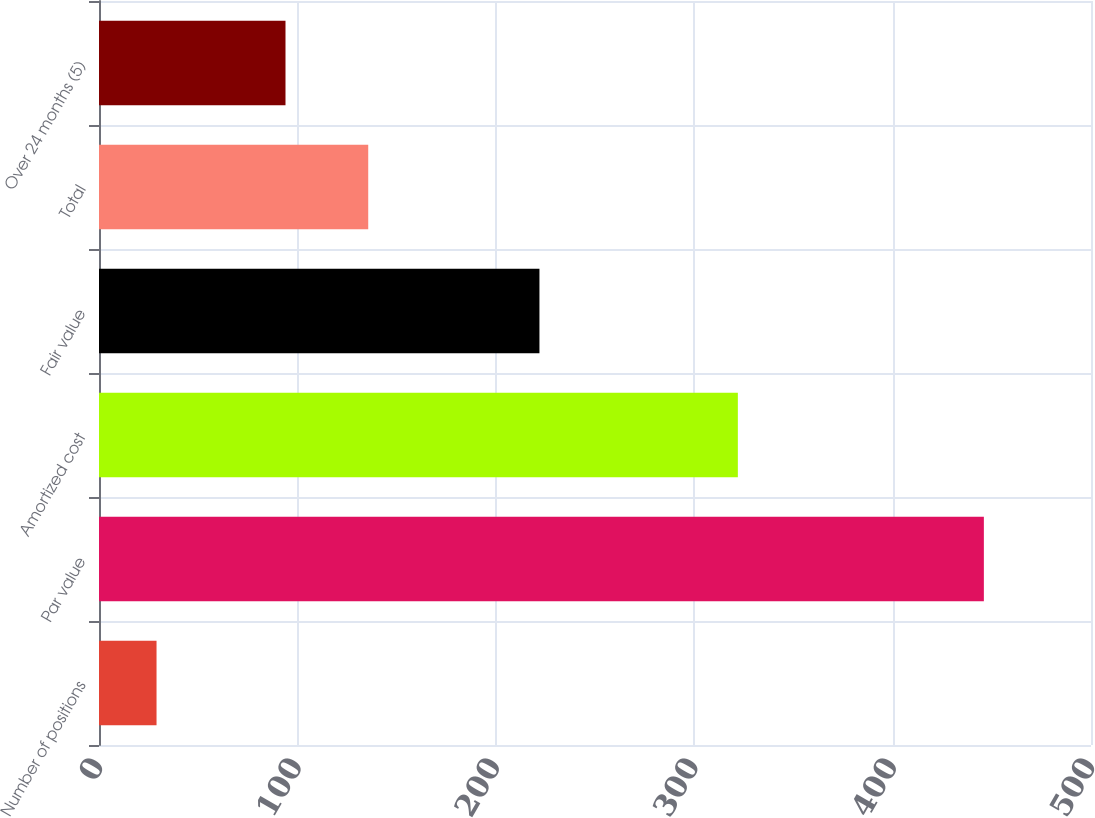Convert chart to OTSL. <chart><loc_0><loc_0><loc_500><loc_500><bar_chart><fcel>Number of positions<fcel>Par value<fcel>Amortized cost<fcel>Fair value<fcel>Total<fcel>Over 24 months (5)<nl><fcel>29<fcel>446<fcel>322<fcel>222<fcel>135.7<fcel>94<nl></chart> 